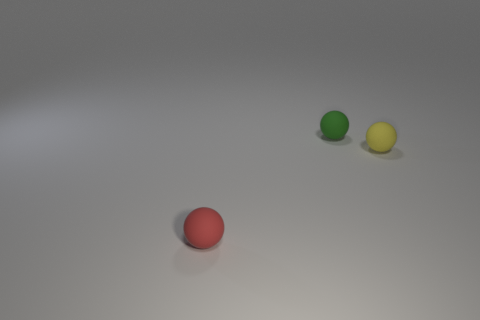There is a tiny thing that is to the right of the tiny red matte ball and in front of the green rubber thing; what shape is it?
Offer a terse response. Sphere. Is there a small green object that has the same material as the red object?
Provide a short and direct response. Yes. What number of tiny rubber objects are to the left of the green object and behind the small red rubber object?
Offer a very short reply. 0. How many things are either tiny red rubber objects or yellow rubber objects?
Your answer should be compact. 2. What color is the matte ball that is behind the small yellow rubber ball?
Give a very brief answer. Green. There is a red matte object that is the same shape as the green rubber object; what is its size?
Ensure brevity in your answer.  Small. How many things are small things that are right of the small green sphere or rubber objects right of the green sphere?
Provide a short and direct response. 1. There is a matte object that is both in front of the green rubber object and behind the red thing; what is its size?
Ensure brevity in your answer.  Small. How many objects are either balls behind the red rubber sphere or tiny metallic spheres?
Your response must be concise. 2. What is the shape of the matte thing on the right side of the tiny matte ball that is behind the tiny yellow object?
Your answer should be very brief. Sphere. 